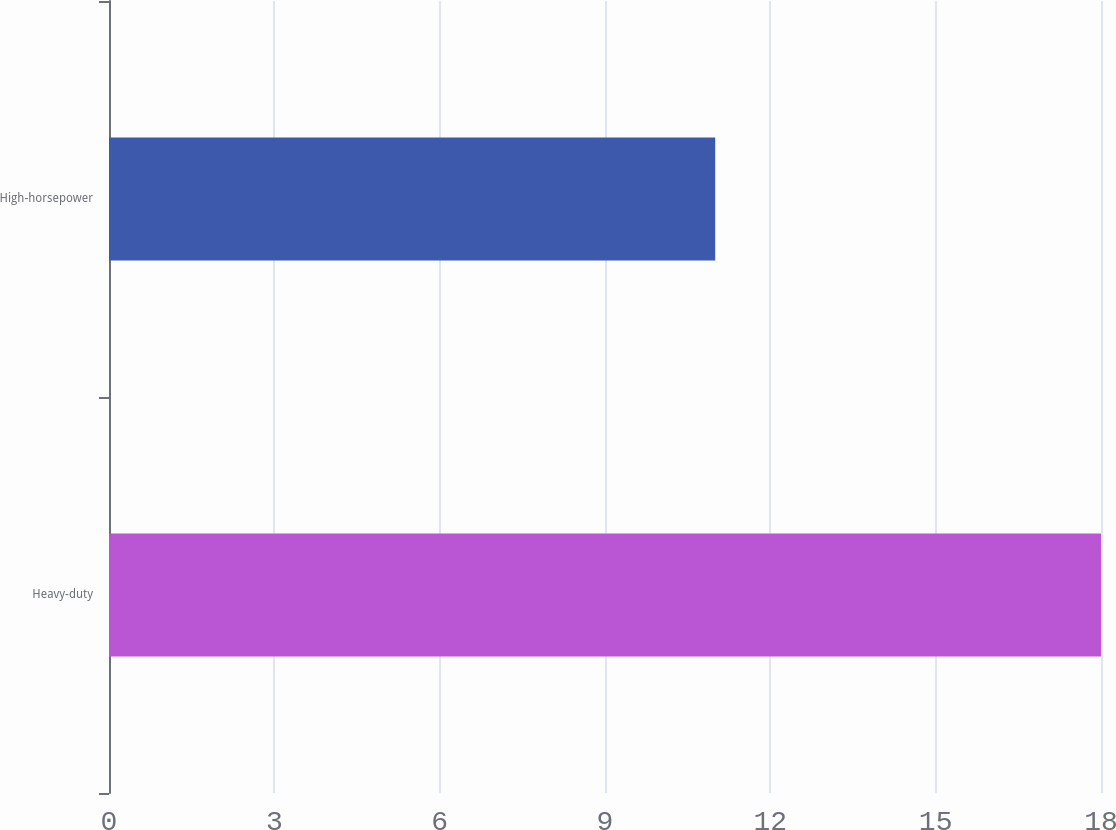Convert chart to OTSL. <chart><loc_0><loc_0><loc_500><loc_500><bar_chart><fcel>Heavy-duty<fcel>High-horsepower<nl><fcel>18<fcel>11<nl></chart> 